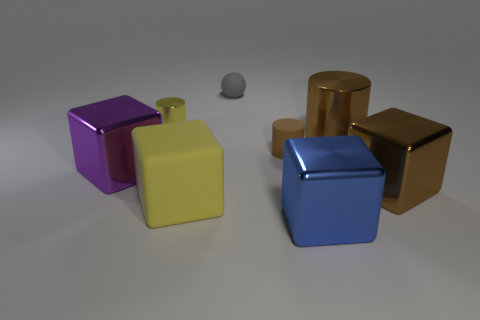Is the color of the small shiny cylinder the same as the matte block?
Offer a terse response. Yes. What shape is the tiny metal object that is the same color as the big matte cube?
Provide a succinct answer. Cylinder. Are there any brown spheres that have the same material as the big brown block?
Provide a short and direct response. No. There is another cylinder that is the same color as the matte cylinder; what is its size?
Keep it short and to the point. Large. What number of spheres are either purple shiny things or tiny brown things?
Ensure brevity in your answer.  0. How big is the blue shiny cube?
Keep it short and to the point. Large. What number of tiny brown matte objects are behind the gray matte object?
Offer a terse response. 0. How big is the metallic cube that is left of the yellow thing in front of the tiny metal thing?
Provide a succinct answer. Large. Is the shape of the large object that is right of the big brown cylinder the same as the big shiny thing left of the blue metallic object?
Offer a terse response. Yes. The large brown thing in front of the rubber object that is to the right of the gray rubber object is what shape?
Offer a very short reply. Cube. 